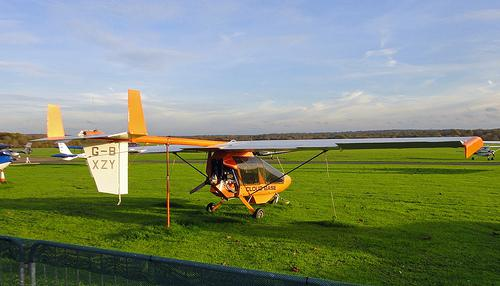Question: how are the visibility conditions?
Choices:
A. No visibility.
B. Very good, the sky is mostly clear.
C. Slight visability.
D. Fog clearing ahead  visability mild.
Answer with the letter. Answer: B Question: how is this aircraft unusual?
Choices:
A. It can land in the water.
B. It can travel in the water.
C. The body of the craft is very short.
D. It can float in the water.
Answer with the letter. Answer: C Question: what color is the aircraft in the middle?
Choices:
A. Yellow.
B. Blue.
C. Grey.
D. Black.
Answer with the letter. Answer: A Question: where is the aircraft with blue trim?
Choices:
A. On the left side.
B. At the airport.
C. In a hangar.
D. Flying in the sky.
Answer with the letter. Answer: A Question: when was the photo taken?
Choices:
A. Last winter.
B. In the fall.
C. In the Spring.
D. In the morning.
Answer with the letter. Answer: D Question: what letters are on the tail?
Choices:
A. Usaf.
B. G,B,X,Z.
C. Army.
D. Marines.
Answer with the letter. Answer: B Question: where is the black fence?
Choices:
A. In the foreground at the edge of the field.
B. In the picture.
C. At the farm.
D. In the movie.
Answer with the letter. Answer: A 